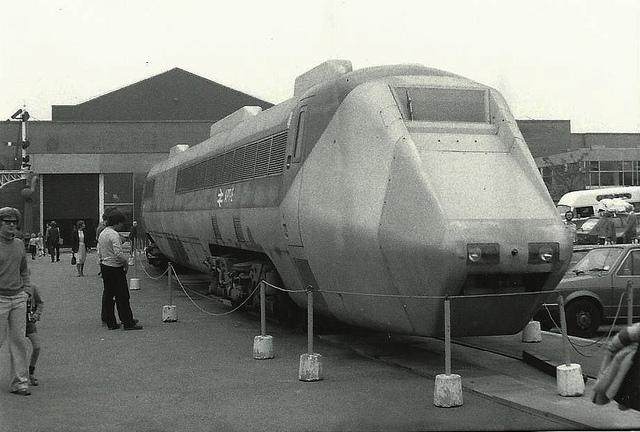Where is this train located? museum 